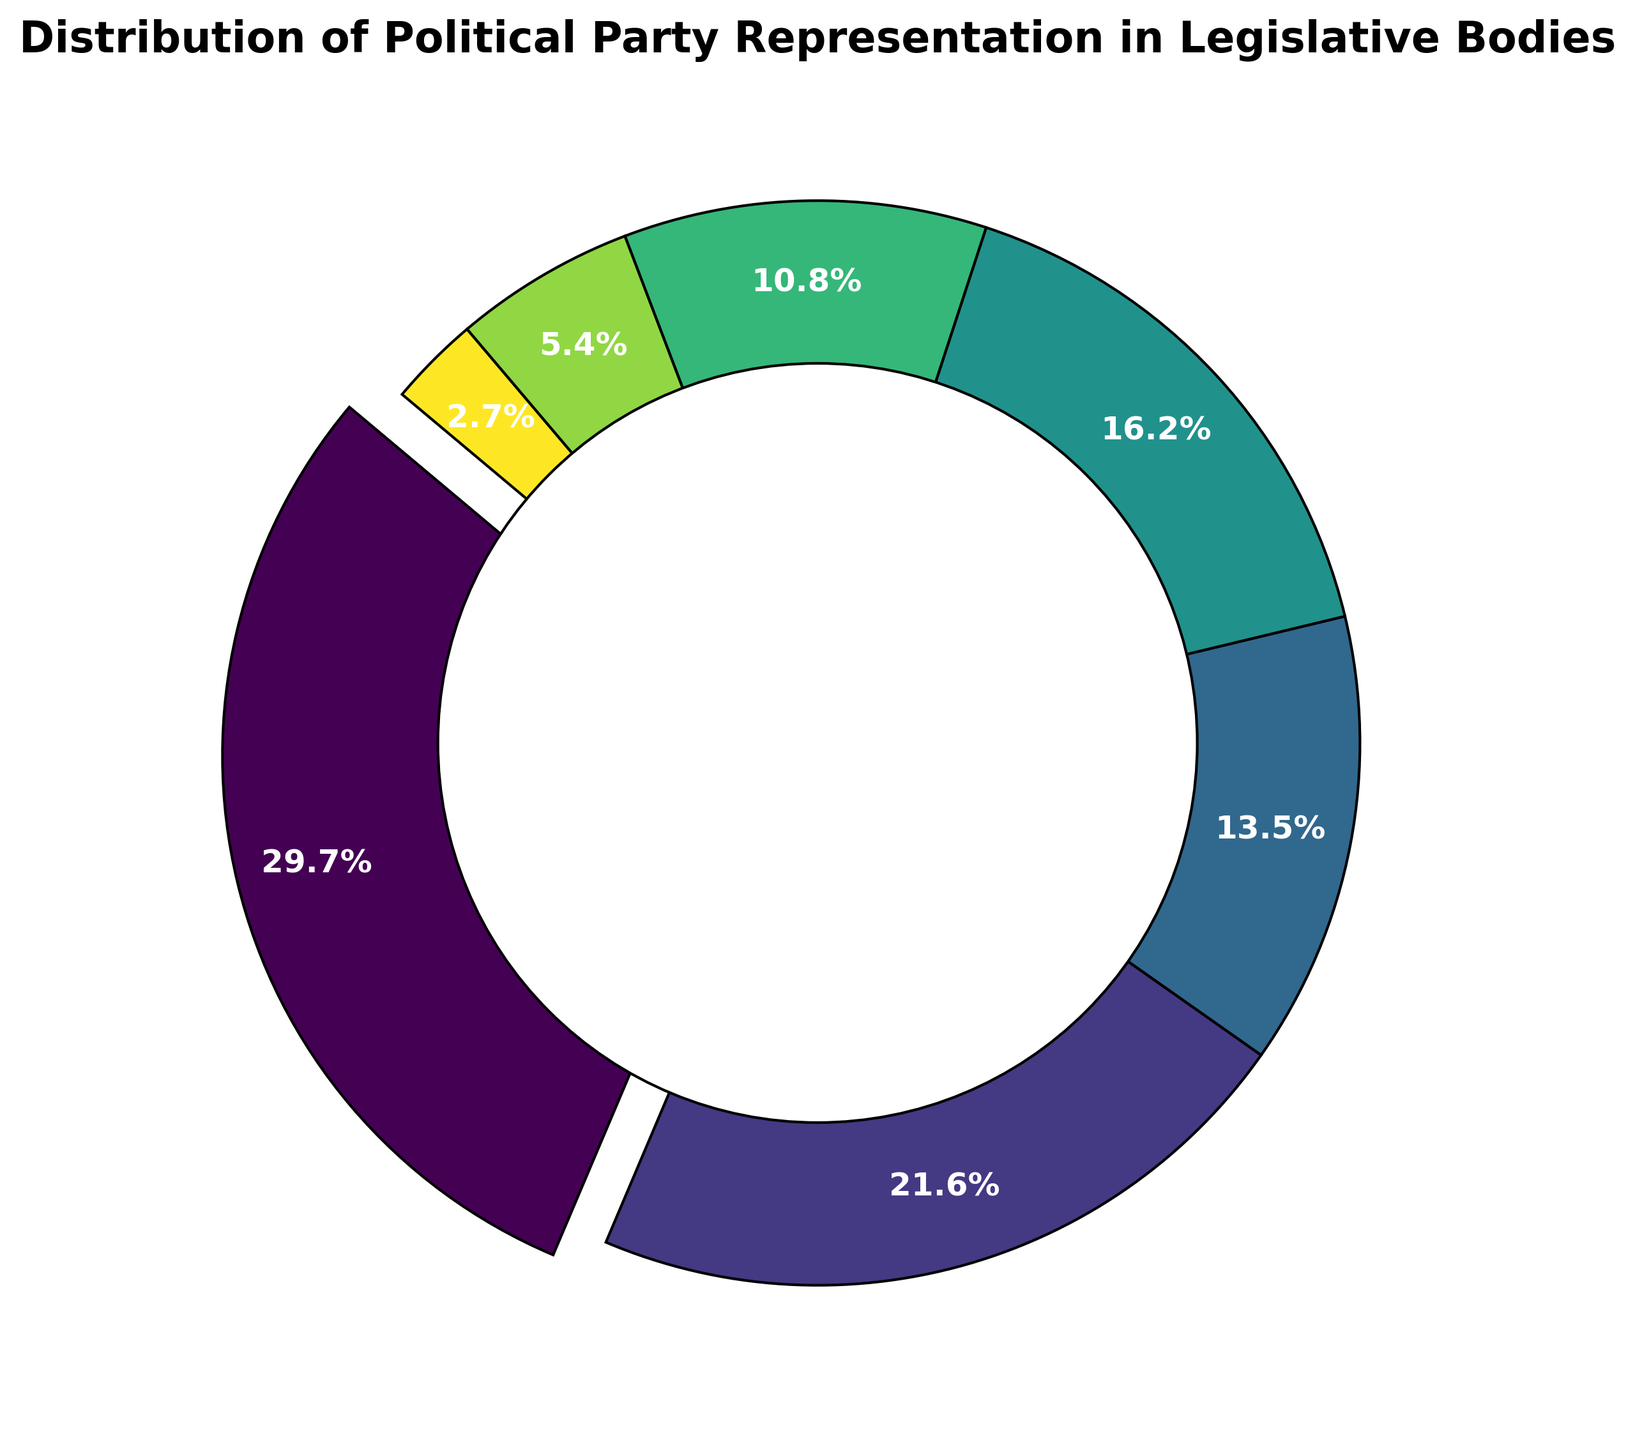What's the percentage representation of Party A? First, locate Party A on the ring chart. The percentage is displayed via the auto text in the figure. Party A has the highest number of seats (55), causing it to be highlighted with an explosion. The auto text shows that Party A covers 32.4% of the chart.
Answer: 32.4% Which party has the least representation and what is its percentage? Find the party with the smallest segment in the ring chart, which is Party G. The auto text shows its percentage as 2.9%.
Answer: Party G, 2.9% How many more seats does Party A have compared to Party C and Party D combined? First, find the seat counts for Party A (55), Party C (25), and Party D (30). Add the seats for Party C and Party D (25 + 30 = 55). Subtract this sum from Party A's seats (55 - 55 = 0).
Answer: 0 What is the difference in percentage between Party B and Party D? Locate the percentages for Party B (23.5%) and Party D (17.6%) from the ring chart auto text. Subtract Party D's percentage from Party B's percentage (23.5% - 17.6% = 5.9%).
Answer: 5.9% Which parties have a representation percentage greater than 10%? Identify parties whose segments are larger than 10% in the ring chart. From the figure, Party A (32.4%), Party B (23.5%), and Party D (17.6%) have segments larger than 10%.
Answer: Party A, Party B, Party D What's the combined percentage of the least represented three parties? Find the percentages for the three smallest parties: Party E (11.8%), Party F (5.9%), and Party G (2.9%). Sum these percentages (11.8% + 5.9% + 2.9% = 20.6%).
Answer: 20.6% Which party's segment is visually the darkest and what percentage does it represent? Identify the darkest segment visually, which aligns with Party G using the viridis colormap. The auto text shows it represents 2.9%.
Answer: Party G, 2.9% What's the most significant visual difference between Party A and Party E? Party A's segment is the largest and emphasized with an explosion, representing 32.4% of the seats. Party E's segment is much smaller without an explosion and represents 11.8% of the seats. The visual difference is thus both in size and the lack of emphasis for Party E.
Answer: Size and explosion, 32.4% vs 11.8% How many times larger is Party B's representation than Party F's? Find Party B and Party F's proportions from the chart, which are 23.5% and 5.9%, respectively. Divide these percentages (23.5% / 5.9% ≈ 3.98).
Answer: Approximately 4 times 